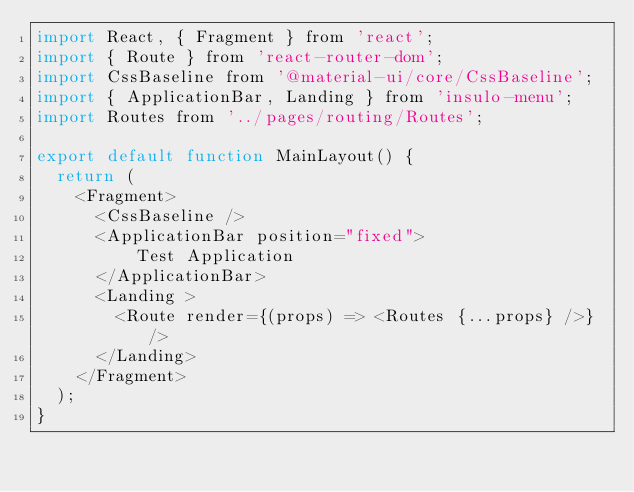Convert code to text. <code><loc_0><loc_0><loc_500><loc_500><_JavaScript_>import React, { Fragment } from 'react';
import { Route } from 'react-router-dom';
import CssBaseline from '@material-ui/core/CssBaseline';
import { ApplicationBar, Landing } from 'insulo-menu';
import Routes from '../pages/routing/Routes';

export default function MainLayout() {
  return (
    <Fragment>
      <CssBaseline />
      <ApplicationBar position="fixed">
          Test Application
      </ApplicationBar>
      <Landing >
        <Route render={(props) => <Routes {...props} />} />
      </Landing>
    </Fragment>
  );
}
</code> 